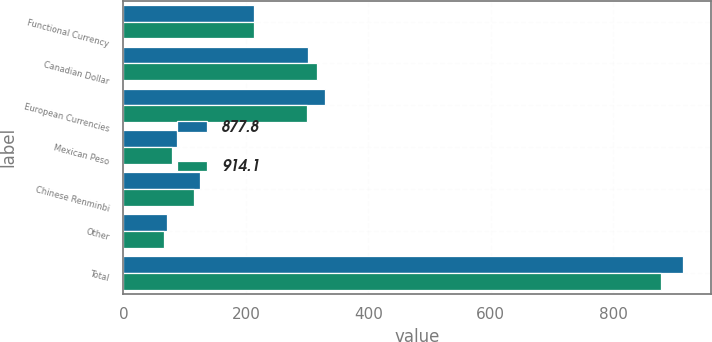<chart> <loc_0><loc_0><loc_500><loc_500><stacked_bar_chart><ecel><fcel>Functional Currency<fcel>Canadian Dollar<fcel>European Currencies<fcel>Mexican Peso<fcel>Chinese Renminbi<fcel>Other<fcel>Total<nl><fcel>877.8<fcel>212.65<fcel>301.4<fcel>328.5<fcel>87.7<fcel>125.8<fcel>70.7<fcel>914.1<nl><fcel>914.1<fcel>212.65<fcel>316.9<fcel>299.5<fcel>79.8<fcel>115.7<fcel>65.9<fcel>877.8<nl></chart> 